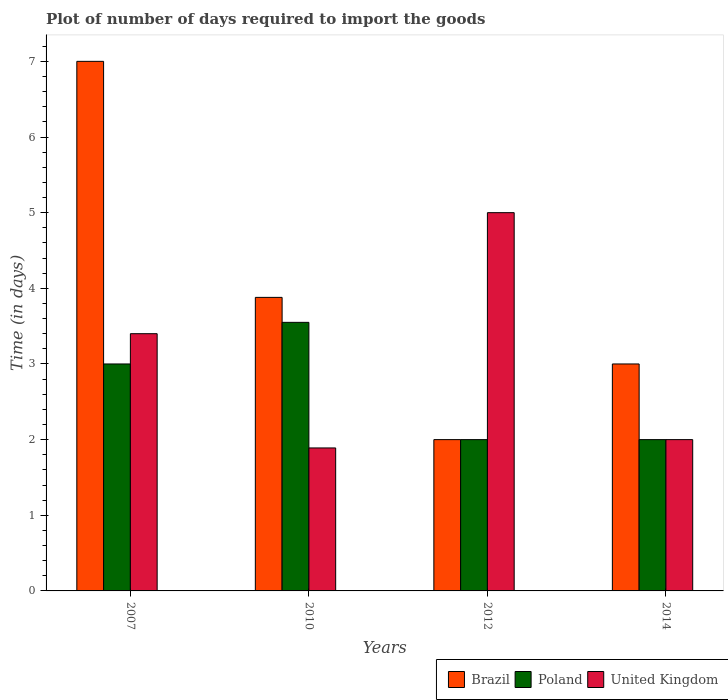How many bars are there on the 4th tick from the right?
Offer a terse response. 3. What is the label of the 3rd group of bars from the left?
Provide a short and direct response. 2012. In how many cases, is the number of bars for a given year not equal to the number of legend labels?
Ensure brevity in your answer.  0. What is the time required to import goods in United Kingdom in 2014?
Your answer should be very brief. 2. Across all years, what is the maximum time required to import goods in Poland?
Offer a very short reply. 3.55. Across all years, what is the minimum time required to import goods in United Kingdom?
Ensure brevity in your answer.  1.89. What is the total time required to import goods in United Kingdom in the graph?
Provide a succinct answer. 12.29. What is the difference between the time required to import goods in Poland in 2007 and the time required to import goods in Brazil in 2010?
Your answer should be very brief. -0.88. What is the average time required to import goods in Brazil per year?
Ensure brevity in your answer.  3.97. In the year 2007, what is the difference between the time required to import goods in United Kingdom and time required to import goods in Brazil?
Offer a terse response. -3.6. In how many years, is the time required to import goods in United Kingdom greater than 7 days?
Give a very brief answer. 0. What is the ratio of the time required to import goods in Brazil in 2007 to that in 2014?
Your response must be concise. 2.33. What is the difference between the highest and the second highest time required to import goods in Poland?
Offer a very short reply. 0.55. What is the difference between the highest and the lowest time required to import goods in Poland?
Make the answer very short. 1.55. What does the 2nd bar from the left in 2014 represents?
Give a very brief answer. Poland. What does the 1st bar from the right in 2010 represents?
Keep it short and to the point. United Kingdom. Is it the case that in every year, the sum of the time required to import goods in United Kingdom and time required to import goods in Poland is greater than the time required to import goods in Brazil?
Ensure brevity in your answer.  No. How many years are there in the graph?
Provide a short and direct response. 4. What is the difference between two consecutive major ticks on the Y-axis?
Give a very brief answer. 1. Are the values on the major ticks of Y-axis written in scientific E-notation?
Your answer should be compact. No. Does the graph contain grids?
Your response must be concise. No. How are the legend labels stacked?
Give a very brief answer. Horizontal. What is the title of the graph?
Your answer should be very brief. Plot of number of days required to import the goods. What is the label or title of the Y-axis?
Your answer should be very brief. Time (in days). What is the Time (in days) of Brazil in 2007?
Keep it short and to the point. 7. What is the Time (in days) in Brazil in 2010?
Ensure brevity in your answer.  3.88. What is the Time (in days) of Poland in 2010?
Offer a terse response. 3.55. What is the Time (in days) in United Kingdom in 2010?
Give a very brief answer. 1.89. What is the Time (in days) of Brazil in 2012?
Your answer should be compact. 2. What is the Time (in days) of Poland in 2012?
Offer a very short reply. 2. What is the Time (in days) in United Kingdom in 2014?
Offer a terse response. 2. Across all years, what is the maximum Time (in days) in Brazil?
Give a very brief answer. 7. Across all years, what is the maximum Time (in days) of Poland?
Your response must be concise. 3.55. Across all years, what is the minimum Time (in days) of Brazil?
Provide a short and direct response. 2. Across all years, what is the minimum Time (in days) in United Kingdom?
Give a very brief answer. 1.89. What is the total Time (in days) of Brazil in the graph?
Offer a very short reply. 15.88. What is the total Time (in days) in Poland in the graph?
Offer a terse response. 10.55. What is the total Time (in days) in United Kingdom in the graph?
Your answer should be compact. 12.29. What is the difference between the Time (in days) in Brazil in 2007 and that in 2010?
Ensure brevity in your answer.  3.12. What is the difference between the Time (in days) of Poland in 2007 and that in 2010?
Give a very brief answer. -0.55. What is the difference between the Time (in days) of United Kingdom in 2007 and that in 2010?
Your response must be concise. 1.51. What is the difference between the Time (in days) in Brazil in 2007 and that in 2012?
Offer a terse response. 5. What is the difference between the Time (in days) of United Kingdom in 2007 and that in 2012?
Provide a short and direct response. -1.6. What is the difference between the Time (in days) of Brazil in 2007 and that in 2014?
Your answer should be compact. 4. What is the difference between the Time (in days) in Poland in 2007 and that in 2014?
Give a very brief answer. 1. What is the difference between the Time (in days) of Brazil in 2010 and that in 2012?
Offer a terse response. 1.88. What is the difference between the Time (in days) of Poland in 2010 and that in 2012?
Ensure brevity in your answer.  1.55. What is the difference between the Time (in days) in United Kingdom in 2010 and that in 2012?
Give a very brief answer. -3.11. What is the difference between the Time (in days) in Brazil in 2010 and that in 2014?
Keep it short and to the point. 0.88. What is the difference between the Time (in days) in Poland in 2010 and that in 2014?
Your answer should be very brief. 1.55. What is the difference between the Time (in days) of United Kingdom in 2010 and that in 2014?
Make the answer very short. -0.11. What is the difference between the Time (in days) in Brazil in 2012 and that in 2014?
Give a very brief answer. -1. What is the difference between the Time (in days) in Brazil in 2007 and the Time (in days) in Poland in 2010?
Offer a terse response. 3.45. What is the difference between the Time (in days) in Brazil in 2007 and the Time (in days) in United Kingdom in 2010?
Offer a very short reply. 5.11. What is the difference between the Time (in days) in Poland in 2007 and the Time (in days) in United Kingdom in 2010?
Provide a short and direct response. 1.11. What is the difference between the Time (in days) of Brazil in 2010 and the Time (in days) of Poland in 2012?
Provide a short and direct response. 1.88. What is the difference between the Time (in days) in Brazil in 2010 and the Time (in days) in United Kingdom in 2012?
Your response must be concise. -1.12. What is the difference between the Time (in days) in Poland in 2010 and the Time (in days) in United Kingdom in 2012?
Keep it short and to the point. -1.45. What is the difference between the Time (in days) in Brazil in 2010 and the Time (in days) in Poland in 2014?
Your answer should be compact. 1.88. What is the difference between the Time (in days) of Brazil in 2010 and the Time (in days) of United Kingdom in 2014?
Give a very brief answer. 1.88. What is the difference between the Time (in days) in Poland in 2010 and the Time (in days) in United Kingdom in 2014?
Provide a short and direct response. 1.55. What is the difference between the Time (in days) of Brazil in 2012 and the Time (in days) of Poland in 2014?
Your response must be concise. 0. What is the difference between the Time (in days) in Poland in 2012 and the Time (in days) in United Kingdom in 2014?
Provide a succinct answer. 0. What is the average Time (in days) in Brazil per year?
Your answer should be compact. 3.97. What is the average Time (in days) of Poland per year?
Offer a terse response. 2.64. What is the average Time (in days) of United Kingdom per year?
Give a very brief answer. 3.07. In the year 2007, what is the difference between the Time (in days) in Poland and Time (in days) in United Kingdom?
Your answer should be very brief. -0.4. In the year 2010, what is the difference between the Time (in days) of Brazil and Time (in days) of Poland?
Your answer should be very brief. 0.33. In the year 2010, what is the difference between the Time (in days) of Brazil and Time (in days) of United Kingdom?
Offer a terse response. 1.99. In the year 2010, what is the difference between the Time (in days) of Poland and Time (in days) of United Kingdom?
Your response must be concise. 1.66. In the year 2012, what is the difference between the Time (in days) of Brazil and Time (in days) of Poland?
Give a very brief answer. 0. In the year 2012, what is the difference between the Time (in days) in Brazil and Time (in days) in United Kingdom?
Provide a succinct answer. -3. In the year 2012, what is the difference between the Time (in days) in Poland and Time (in days) in United Kingdom?
Keep it short and to the point. -3. In the year 2014, what is the difference between the Time (in days) of Brazil and Time (in days) of Poland?
Ensure brevity in your answer.  1. In the year 2014, what is the difference between the Time (in days) in Poland and Time (in days) in United Kingdom?
Give a very brief answer. 0. What is the ratio of the Time (in days) of Brazil in 2007 to that in 2010?
Your answer should be very brief. 1.8. What is the ratio of the Time (in days) of Poland in 2007 to that in 2010?
Provide a short and direct response. 0.85. What is the ratio of the Time (in days) of United Kingdom in 2007 to that in 2010?
Give a very brief answer. 1.8. What is the ratio of the Time (in days) of Brazil in 2007 to that in 2012?
Keep it short and to the point. 3.5. What is the ratio of the Time (in days) in United Kingdom in 2007 to that in 2012?
Offer a terse response. 0.68. What is the ratio of the Time (in days) in Brazil in 2007 to that in 2014?
Provide a short and direct response. 2.33. What is the ratio of the Time (in days) of Poland in 2007 to that in 2014?
Provide a succinct answer. 1.5. What is the ratio of the Time (in days) in Brazil in 2010 to that in 2012?
Your response must be concise. 1.94. What is the ratio of the Time (in days) in Poland in 2010 to that in 2012?
Offer a very short reply. 1.77. What is the ratio of the Time (in days) of United Kingdom in 2010 to that in 2012?
Offer a terse response. 0.38. What is the ratio of the Time (in days) of Brazil in 2010 to that in 2014?
Offer a terse response. 1.29. What is the ratio of the Time (in days) of Poland in 2010 to that in 2014?
Ensure brevity in your answer.  1.77. What is the ratio of the Time (in days) in United Kingdom in 2010 to that in 2014?
Ensure brevity in your answer.  0.94. What is the ratio of the Time (in days) of Poland in 2012 to that in 2014?
Give a very brief answer. 1. What is the ratio of the Time (in days) of United Kingdom in 2012 to that in 2014?
Offer a terse response. 2.5. What is the difference between the highest and the second highest Time (in days) of Brazil?
Keep it short and to the point. 3.12. What is the difference between the highest and the second highest Time (in days) of Poland?
Keep it short and to the point. 0.55. What is the difference between the highest and the lowest Time (in days) in Brazil?
Provide a succinct answer. 5. What is the difference between the highest and the lowest Time (in days) in Poland?
Make the answer very short. 1.55. What is the difference between the highest and the lowest Time (in days) in United Kingdom?
Provide a short and direct response. 3.11. 